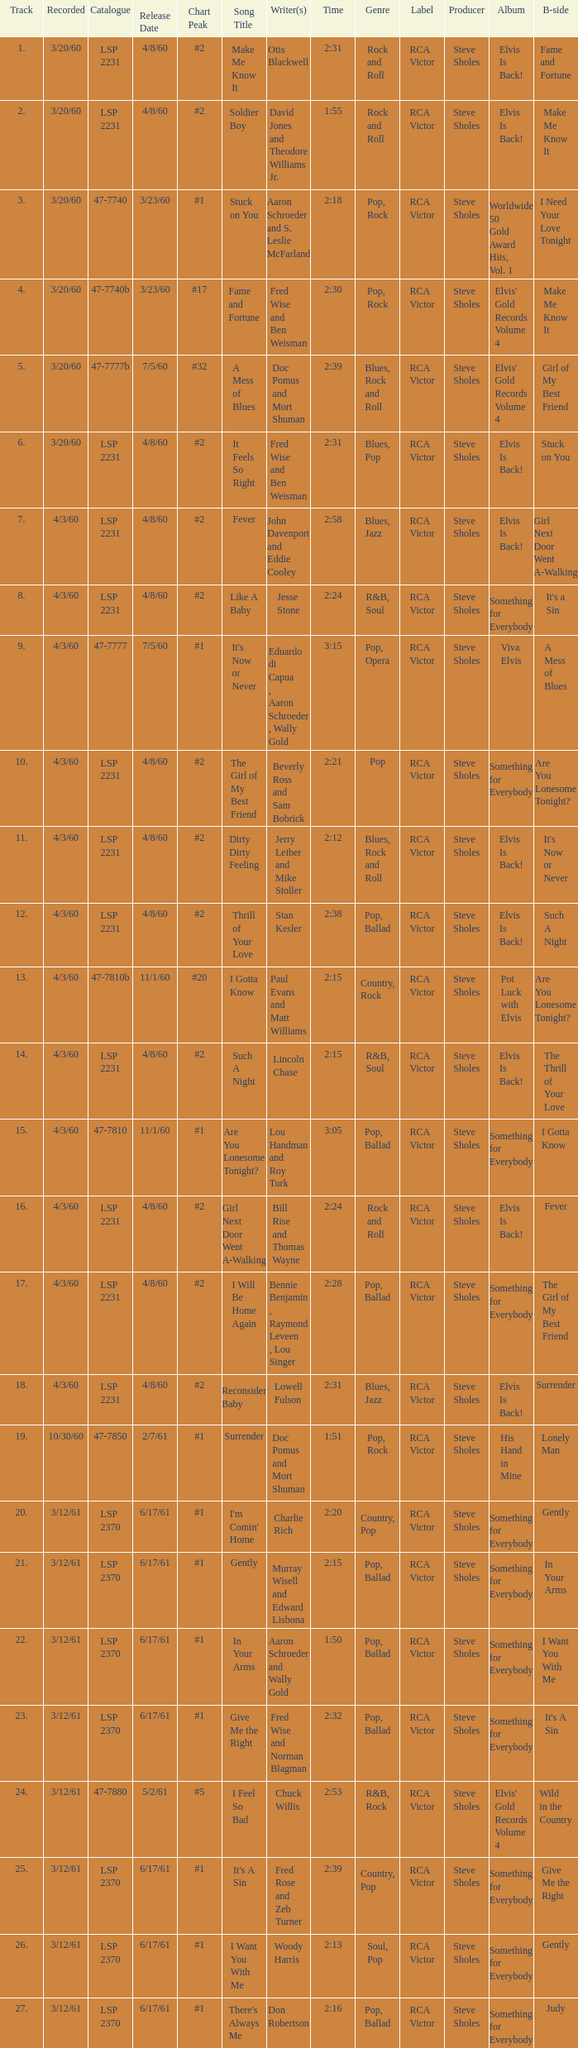On songs that have a release date of 6/17/61, a track larger than 20, and a writer of Woody Harris, what is the chart peak? #1. 